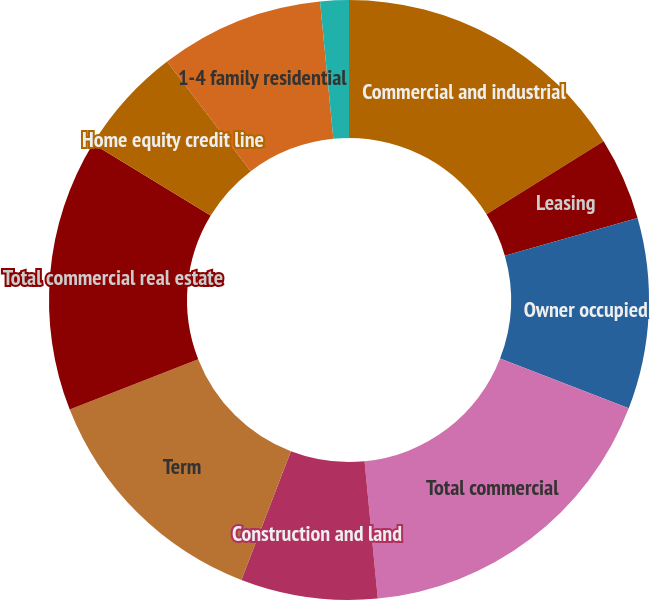Convert chart. <chart><loc_0><loc_0><loc_500><loc_500><pie_chart><fcel>Commercial and industrial<fcel>Leasing<fcel>Owner occupied<fcel>Total commercial<fcel>Construction and land<fcel>Term<fcel>Total commercial real estate<fcel>Home equity credit line<fcel>1-4 family residential<fcel>Construction and other<nl><fcel>16.13%<fcel>4.46%<fcel>10.29%<fcel>17.59%<fcel>7.37%<fcel>13.21%<fcel>14.67%<fcel>5.91%<fcel>8.83%<fcel>1.54%<nl></chart> 